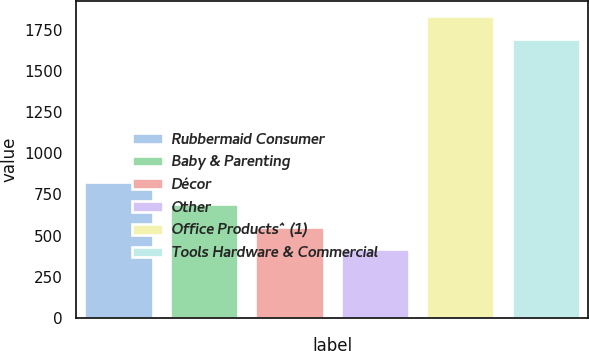Convert chart to OTSL. <chart><loc_0><loc_0><loc_500><loc_500><bar_chart><fcel>Rubbermaid Consumer<fcel>Baby & Parenting<fcel>Décor<fcel>Other<fcel>Office Products^ (1)<fcel>Tools Hardware & Commercial<nl><fcel>827.2<fcel>690.24<fcel>554.17<fcel>418.1<fcel>1831.37<fcel>1695.3<nl></chart> 